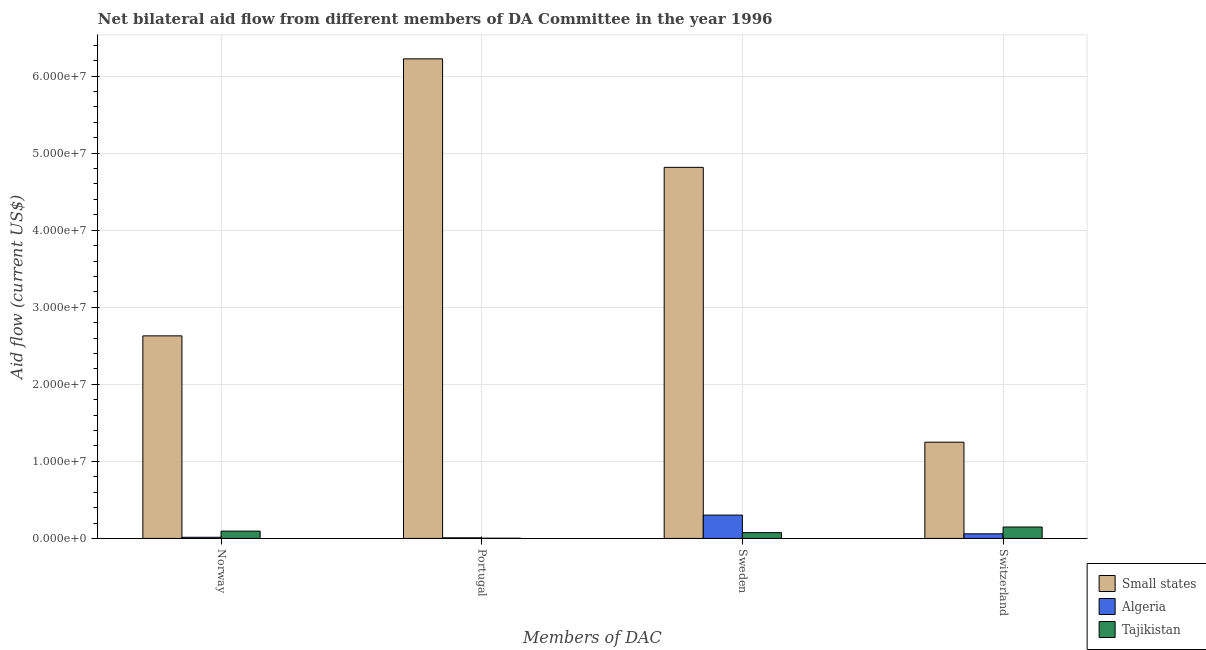Are the number of bars per tick equal to the number of legend labels?
Your response must be concise. Yes. Are the number of bars on each tick of the X-axis equal?
Provide a short and direct response. Yes. How many bars are there on the 3rd tick from the right?
Keep it short and to the point. 3. What is the amount of aid given by norway in Algeria?
Your response must be concise. 1.50e+05. Across all countries, what is the maximum amount of aid given by switzerland?
Make the answer very short. 1.25e+07. Across all countries, what is the minimum amount of aid given by switzerland?
Offer a very short reply. 6.00e+05. In which country was the amount of aid given by switzerland maximum?
Keep it short and to the point. Small states. In which country was the amount of aid given by norway minimum?
Provide a succinct answer. Algeria. What is the total amount of aid given by switzerland in the graph?
Your answer should be compact. 1.46e+07. What is the difference between the amount of aid given by portugal in Tajikistan and that in Small states?
Your answer should be compact. -6.22e+07. What is the difference between the amount of aid given by portugal in Small states and the amount of aid given by switzerland in Tajikistan?
Ensure brevity in your answer.  6.08e+07. What is the average amount of aid given by norway per country?
Your answer should be very brief. 9.13e+06. What is the difference between the amount of aid given by portugal and amount of aid given by norway in Small states?
Offer a terse response. 3.60e+07. In how many countries, is the amount of aid given by norway greater than 6000000 US$?
Provide a short and direct response. 1. What is the ratio of the amount of aid given by switzerland in Small states to that in Algeria?
Offer a very short reply. 20.82. Is the amount of aid given by switzerland in Algeria less than that in Tajikistan?
Ensure brevity in your answer.  Yes. Is the difference between the amount of aid given by sweden in Small states and Tajikistan greater than the difference between the amount of aid given by switzerland in Small states and Tajikistan?
Your response must be concise. Yes. What is the difference between the highest and the second highest amount of aid given by portugal?
Offer a terse response. 6.22e+07. What is the difference between the highest and the lowest amount of aid given by portugal?
Provide a succinct answer. 6.22e+07. Is it the case that in every country, the sum of the amount of aid given by sweden and amount of aid given by switzerland is greater than the sum of amount of aid given by portugal and amount of aid given by norway?
Your response must be concise. No. What does the 2nd bar from the left in Sweden represents?
Provide a short and direct response. Algeria. What does the 2nd bar from the right in Sweden represents?
Offer a terse response. Algeria. How many bars are there?
Provide a short and direct response. 12. Are all the bars in the graph horizontal?
Your response must be concise. No. How many countries are there in the graph?
Give a very brief answer. 3. Where does the legend appear in the graph?
Keep it short and to the point. Bottom right. How are the legend labels stacked?
Keep it short and to the point. Vertical. What is the title of the graph?
Your response must be concise. Net bilateral aid flow from different members of DA Committee in the year 1996. Does "Paraguay" appear as one of the legend labels in the graph?
Ensure brevity in your answer.  No. What is the label or title of the X-axis?
Keep it short and to the point. Members of DAC. What is the Aid flow (current US$) of Small states in Norway?
Make the answer very short. 2.63e+07. What is the Aid flow (current US$) of Tajikistan in Norway?
Provide a short and direct response. 9.50e+05. What is the Aid flow (current US$) of Small states in Portugal?
Your response must be concise. 6.22e+07. What is the Aid flow (current US$) of Algeria in Portugal?
Offer a very short reply. 8.00e+04. What is the Aid flow (current US$) of Tajikistan in Portugal?
Offer a terse response. 3.00e+04. What is the Aid flow (current US$) of Small states in Sweden?
Give a very brief answer. 4.82e+07. What is the Aid flow (current US$) of Algeria in Sweden?
Your answer should be compact. 3.03e+06. What is the Aid flow (current US$) of Tajikistan in Sweden?
Provide a short and direct response. 7.50e+05. What is the Aid flow (current US$) of Small states in Switzerland?
Provide a succinct answer. 1.25e+07. What is the Aid flow (current US$) in Algeria in Switzerland?
Keep it short and to the point. 6.00e+05. What is the Aid flow (current US$) of Tajikistan in Switzerland?
Give a very brief answer. 1.48e+06. Across all Members of DAC, what is the maximum Aid flow (current US$) of Small states?
Make the answer very short. 6.22e+07. Across all Members of DAC, what is the maximum Aid flow (current US$) of Algeria?
Keep it short and to the point. 3.03e+06. Across all Members of DAC, what is the maximum Aid flow (current US$) in Tajikistan?
Ensure brevity in your answer.  1.48e+06. Across all Members of DAC, what is the minimum Aid flow (current US$) of Small states?
Keep it short and to the point. 1.25e+07. What is the total Aid flow (current US$) of Small states in the graph?
Your answer should be compact. 1.49e+08. What is the total Aid flow (current US$) of Algeria in the graph?
Your answer should be compact. 3.86e+06. What is the total Aid flow (current US$) of Tajikistan in the graph?
Give a very brief answer. 3.21e+06. What is the difference between the Aid flow (current US$) of Small states in Norway and that in Portugal?
Give a very brief answer. -3.60e+07. What is the difference between the Aid flow (current US$) of Tajikistan in Norway and that in Portugal?
Keep it short and to the point. 9.20e+05. What is the difference between the Aid flow (current US$) in Small states in Norway and that in Sweden?
Offer a terse response. -2.19e+07. What is the difference between the Aid flow (current US$) of Algeria in Norway and that in Sweden?
Make the answer very short. -2.88e+06. What is the difference between the Aid flow (current US$) of Small states in Norway and that in Switzerland?
Your response must be concise. 1.38e+07. What is the difference between the Aid flow (current US$) in Algeria in Norway and that in Switzerland?
Your response must be concise. -4.50e+05. What is the difference between the Aid flow (current US$) in Tajikistan in Norway and that in Switzerland?
Keep it short and to the point. -5.30e+05. What is the difference between the Aid flow (current US$) in Small states in Portugal and that in Sweden?
Keep it short and to the point. 1.41e+07. What is the difference between the Aid flow (current US$) in Algeria in Portugal and that in Sweden?
Provide a short and direct response. -2.95e+06. What is the difference between the Aid flow (current US$) in Tajikistan in Portugal and that in Sweden?
Make the answer very short. -7.20e+05. What is the difference between the Aid flow (current US$) in Small states in Portugal and that in Switzerland?
Provide a short and direct response. 4.98e+07. What is the difference between the Aid flow (current US$) of Algeria in Portugal and that in Switzerland?
Give a very brief answer. -5.20e+05. What is the difference between the Aid flow (current US$) in Tajikistan in Portugal and that in Switzerland?
Ensure brevity in your answer.  -1.45e+06. What is the difference between the Aid flow (current US$) in Small states in Sweden and that in Switzerland?
Provide a short and direct response. 3.57e+07. What is the difference between the Aid flow (current US$) in Algeria in Sweden and that in Switzerland?
Your response must be concise. 2.43e+06. What is the difference between the Aid flow (current US$) of Tajikistan in Sweden and that in Switzerland?
Ensure brevity in your answer.  -7.30e+05. What is the difference between the Aid flow (current US$) in Small states in Norway and the Aid flow (current US$) in Algeria in Portugal?
Your answer should be compact. 2.62e+07. What is the difference between the Aid flow (current US$) of Small states in Norway and the Aid flow (current US$) of Tajikistan in Portugal?
Your answer should be very brief. 2.63e+07. What is the difference between the Aid flow (current US$) of Small states in Norway and the Aid flow (current US$) of Algeria in Sweden?
Offer a very short reply. 2.33e+07. What is the difference between the Aid flow (current US$) in Small states in Norway and the Aid flow (current US$) in Tajikistan in Sweden?
Your answer should be compact. 2.55e+07. What is the difference between the Aid flow (current US$) of Algeria in Norway and the Aid flow (current US$) of Tajikistan in Sweden?
Make the answer very short. -6.00e+05. What is the difference between the Aid flow (current US$) in Small states in Norway and the Aid flow (current US$) in Algeria in Switzerland?
Provide a succinct answer. 2.57e+07. What is the difference between the Aid flow (current US$) in Small states in Norway and the Aid flow (current US$) in Tajikistan in Switzerland?
Give a very brief answer. 2.48e+07. What is the difference between the Aid flow (current US$) in Algeria in Norway and the Aid flow (current US$) in Tajikistan in Switzerland?
Make the answer very short. -1.33e+06. What is the difference between the Aid flow (current US$) in Small states in Portugal and the Aid flow (current US$) in Algeria in Sweden?
Ensure brevity in your answer.  5.92e+07. What is the difference between the Aid flow (current US$) of Small states in Portugal and the Aid flow (current US$) of Tajikistan in Sweden?
Offer a very short reply. 6.15e+07. What is the difference between the Aid flow (current US$) in Algeria in Portugal and the Aid flow (current US$) in Tajikistan in Sweden?
Keep it short and to the point. -6.70e+05. What is the difference between the Aid flow (current US$) in Small states in Portugal and the Aid flow (current US$) in Algeria in Switzerland?
Provide a succinct answer. 6.16e+07. What is the difference between the Aid flow (current US$) of Small states in Portugal and the Aid flow (current US$) of Tajikistan in Switzerland?
Offer a terse response. 6.08e+07. What is the difference between the Aid flow (current US$) of Algeria in Portugal and the Aid flow (current US$) of Tajikistan in Switzerland?
Your answer should be very brief. -1.40e+06. What is the difference between the Aid flow (current US$) in Small states in Sweden and the Aid flow (current US$) in Algeria in Switzerland?
Provide a short and direct response. 4.76e+07. What is the difference between the Aid flow (current US$) in Small states in Sweden and the Aid flow (current US$) in Tajikistan in Switzerland?
Offer a very short reply. 4.67e+07. What is the difference between the Aid flow (current US$) of Algeria in Sweden and the Aid flow (current US$) of Tajikistan in Switzerland?
Offer a very short reply. 1.55e+06. What is the average Aid flow (current US$) in Small states per Members of DAC?
Make the answer very short. 3.73e+07. What is the average Aid flow (current US$) in Algeria per Members of DAC?
Your answer should be compact. 9.65e+05. What is the average Aid flow (current US$) of Tajikistan per Members of DAC?
Your answer should be compact. 8.02e+05. What is the difference between the Aid flow (current US$) in Small states and Aid flow (current US$) in Algeria in Norway?
Your response must be concise. 2.61e+07. What is the difference between the Aid flow (current US$) of Small states and Aid flow (current US$) of Tajikistan in Norway?
Offer a very short reply. 2.53e+07. What is the difference between the Aid flow (current US$) in Algeria and Aid flow (current US$) in Tajikistan in Norway?
Your response must be concise. -8.00e+05. What is the difference between the Aid flow (current US$) of Small states and Aid flow (current US$) of Algeria in Portugal?
Your response must be concise. 6.22e+07. What is the difference between the Aid flow (current US$) of Small states and Aid flow (current US$) of Tajikistan in Portugal?
Provide a succinct answer. 6.22e+07. What is the difference between the Aid flow (current US$) in Small states and Aid flow (current US$) in Algeria in Sweden?
Provide a succinct answer. 4.51e+07. What is the difference between the Aid flow (current US$) of Small states and Aid flow (current US$) of Tajikistan in Sweden?
Provide a short and direct response. 4.74e+07. What is the difference between the Aid flow (current US$) in Algeria and Aid flow (current US$) in Tajikistan in Sweden?
Your answer should be compact. 2.28e+06. What is the difference between the Aid flow (current US$) in Small states and Aid flow (current US$) in Algeria in Switzerland?
Ensure brevity in your answer.  1.19e+07. What is the difference between the Aid flow (current US$) in Small states and Aid flow (current US$) in Tajikistan in Switzerland?
Give a very brief answer. 1.10e+07. What is the difference between the Aid flow (current US$) of Algeria and Aid flow (current US$) of Tajikistan in Switzerland?
Your answer should be very brief. -8.80e+05. What is the ratio of the Aid flow (current US$) in Small states in Norway to that in Portugal?
Keep it short and to the point. 0.42. What is the ratio of the Aid flow (current US$) in Algeria in Norway to that in Portugal?
Provide a succinct answer. 1.88. What is the ratio of the Aid flow (current US$) of Tajikistan in Norway to that in Portugal?
Ensure brevity in your answer.  31.67. What is the ratio of the Aid flow (current US$) of Small states in Norway to that in Sweden?
Make the answer very short. 0.55. What is the ratio of the Aid flow (current US$) in Algeria in Norway to that in Sweden?
Make the answer very short. 0.05. What is the ratio of the Aid flow (current US$) of Tajikistan in Norway to that in Sweden?
Offer a terse response. 1.27. What is the ratio of the Aid flow (current US$) of Small states in Norway to that in Switzerland?
Make the answer very short. 2.1. What is the ratio of the Aid flow (current US$) in Tajikistan in Norway to that in Switzerland?
Provide a succinct answer. 0.64. What is the ratio of the Aid flow (current US$) in Small states in Portugal to that in Sweden?
Your answer should be compact. 1.29. What is the ratio of the Aid flow (current US$) in Algeria in Portugal to that in Sweden?
Offer a terse response. 0.03. What is the ratio of the Aid flow (current US$) of Tajikistan in Portugal to that in Sweden?
Give a very brief answer. 0.04. What is the ratio of the Aid flow (current US$) in Small states in Portugal to that in Switzerland?
Offer a very short reply. 4.98. What is the ratio of the Aid flow (current US$) of Algeria in Portugal to that in Switzerland?
Your answer should be very brief. 0.13. What is the ratio of the Aid flow (current US$) in Tajikistan in Portugal to that in Switzerland?
Your response must be concise. 0.02. What is the ratio of the Aid flow (current US$) in Small states in Sweden to that in Switzerland?
Provide a succinct answer. 3.86. What is the ratio of the Aid flow (current US$) of Algeria in Sweden to that in Switzerland?
Your answer should be compact. 5.05. What is the ratio of the Aid flow (current US$) in Tajikistan in Sweden to that in Switzerland?
Provide a short and direct response. 0.51. What is the difference between the highest and the second highest Aid flow (current US$) of Small states?
Provide a succinct answer. 1.41e+07. What is the difference between the highest and the second highest Aid flow (current US$) in Algeria?
Offer a very short reply. 2.43e+06. What is the difference between the highest and the second highest Aid flow (current US$) of Tajikistan?
Keep it short and to the point. 5.30e+05. What is the difference between the highest and the lowest Aid flow (current US$) in Small states?
Your answer should be very brief. 4.98e+07. What is the difference between the highest and the lowest Aid flow (current US$) of Algeria?
Your answer should be very brief. 2.95e+06. What is the difference between the highest and the lowest Aid flow (current US$) of Tajikistan?
Offer a very short reply. 1.45e+06. 